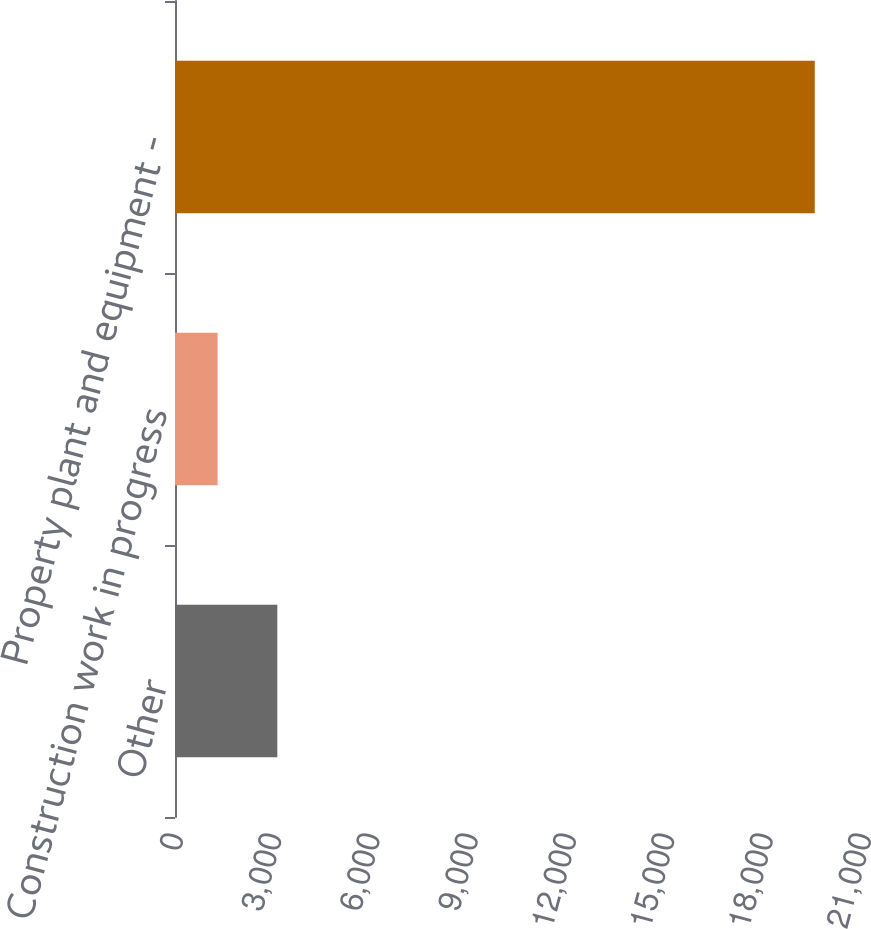Convert chart. <chart><loc_0><loc_0><loc_500><loc_500><bar_chart><fcel>Other<fcel>Construction work in progress<fcel>Property plant and equipment -<nl><fcel>3122.8<fcel>1300<fcel>19528<nl></chart> 